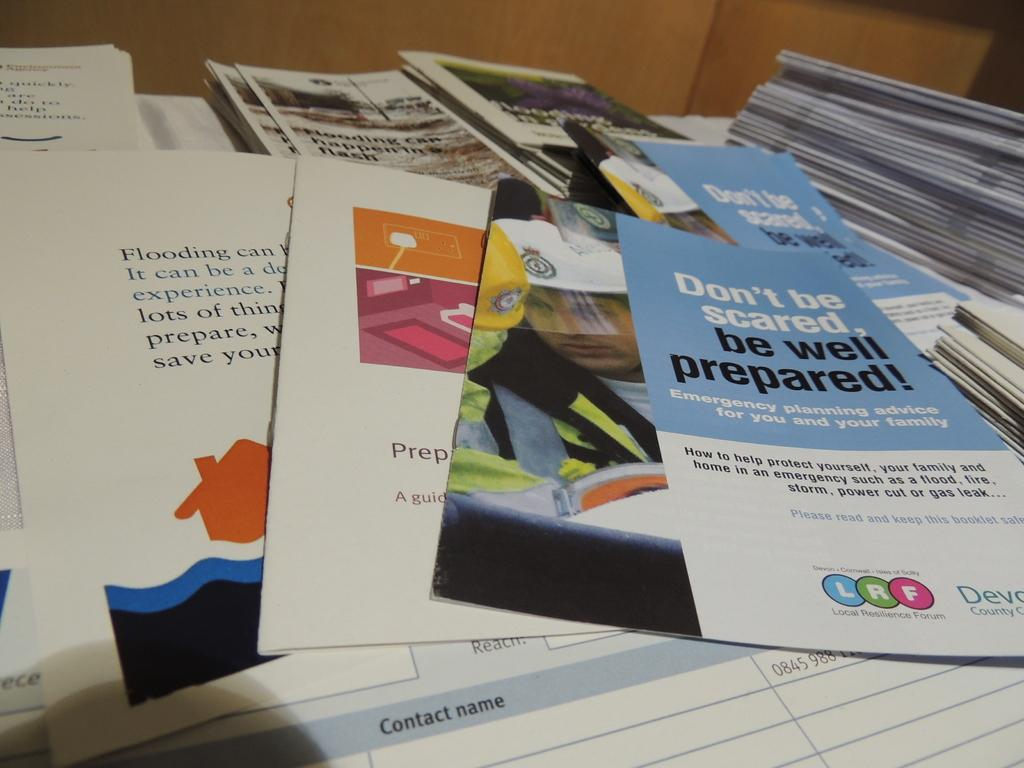<image>
Create a compact narrative representing the image presented. Some fliers about being prepared are stacked on a table. 